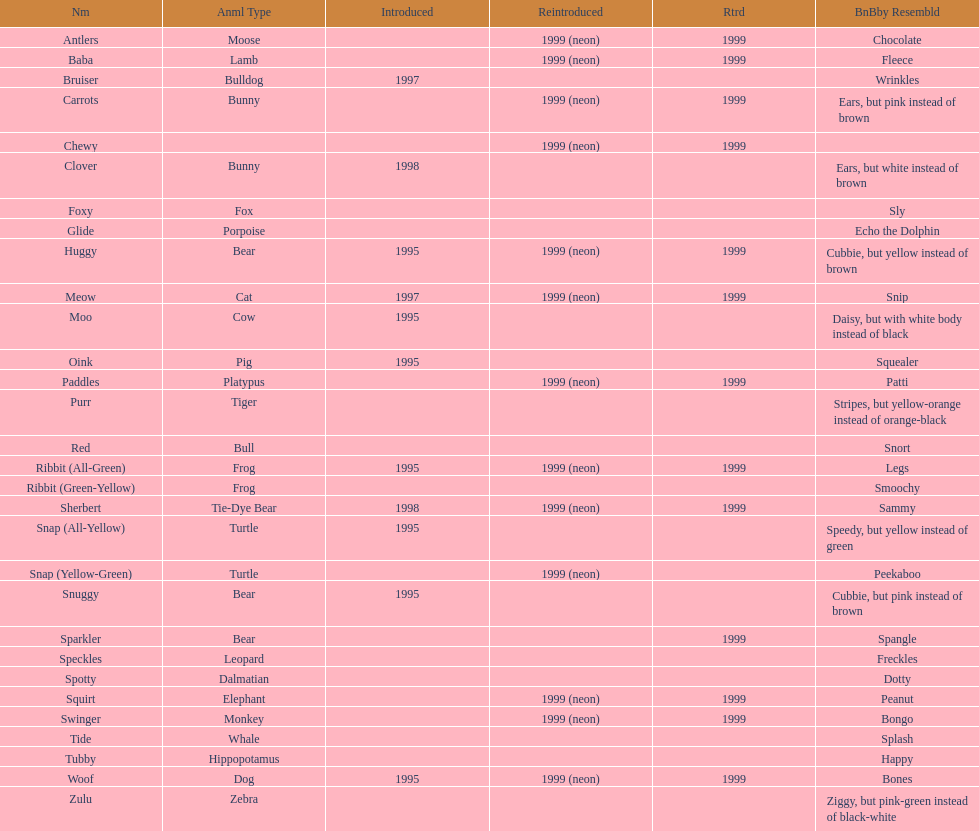Tell me the number of pillow pals reintroduced in 1999. 13. 